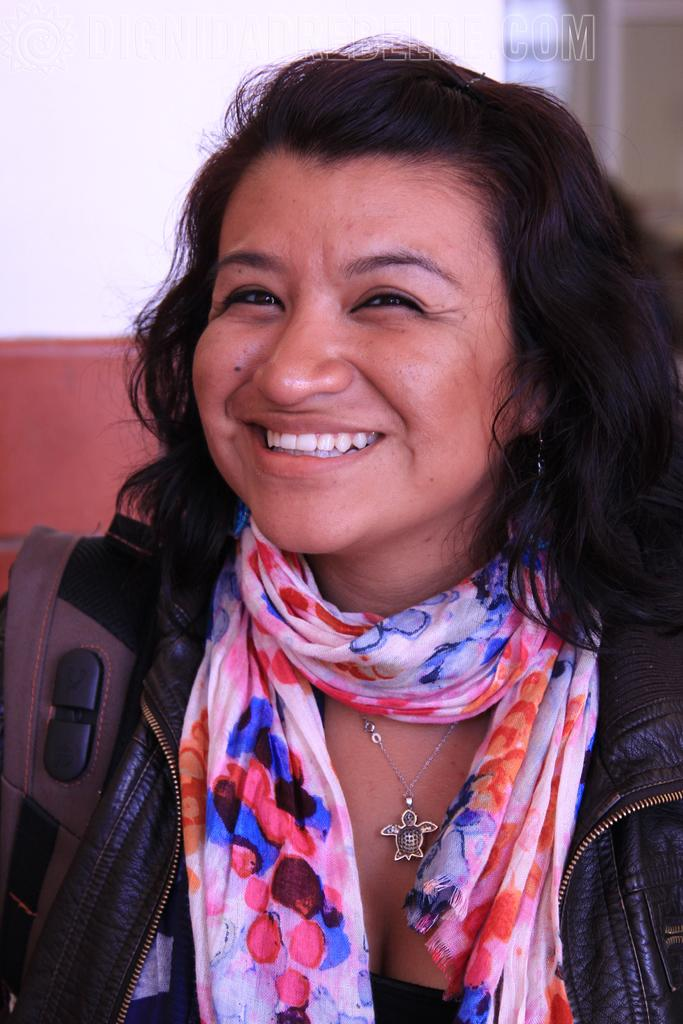Who is present in the image? There is a woman in the image. What is the woman doing in the image? The woman is laughing. What accessories is the woman wearing in the image? The woman is wearing a scarf and a jacket. What can be seen in the background of the image? There is a wall in the background of the image. What type of fork is the woman using to eat in the image? There is no fork present in the image; the woman is laughing and wearing a scarf and a jacket. 